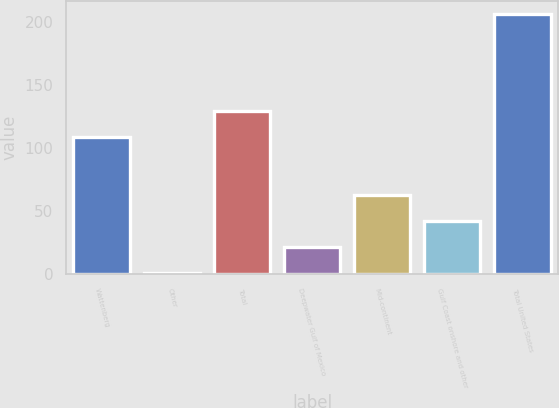<chart> <loc_0><loc_0><loc_500><loc_500><bar_chart><fcel>Wattenberg<fcel>Other<fcel>Total<fcel>Deepwater Gulf of Mexico<fcel>Mid-continent<fcel>Gulf Coast onshore and other<fcel>Total United States<nl><fcel>109<fcel>1<fcel>129.6<fcel>21.6<fcel>62.8<fcel>42.2<fcel>207<nl></chart> 